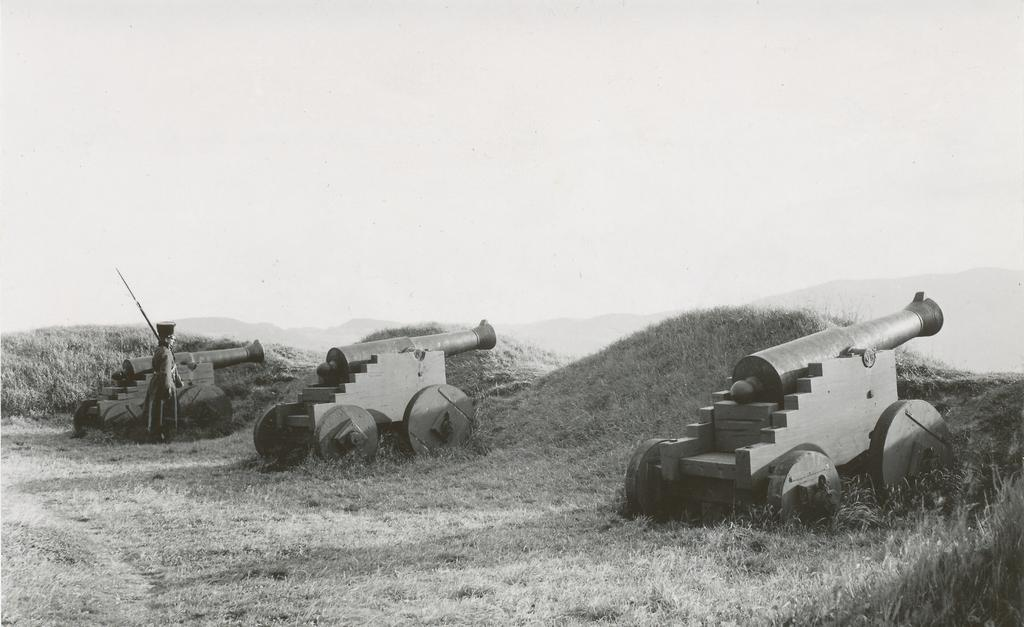What is the color scheme of the image? The image is black and white. What objects are present in the image? There are three cannons in the image. Are there any people in the image? Yes, there is a man standing near one of the cannons. Can you see any roses growing near the cannons in the image? There are no roses present in the image; it is a black and white image featuring three cannons and a man standing near one of them. 